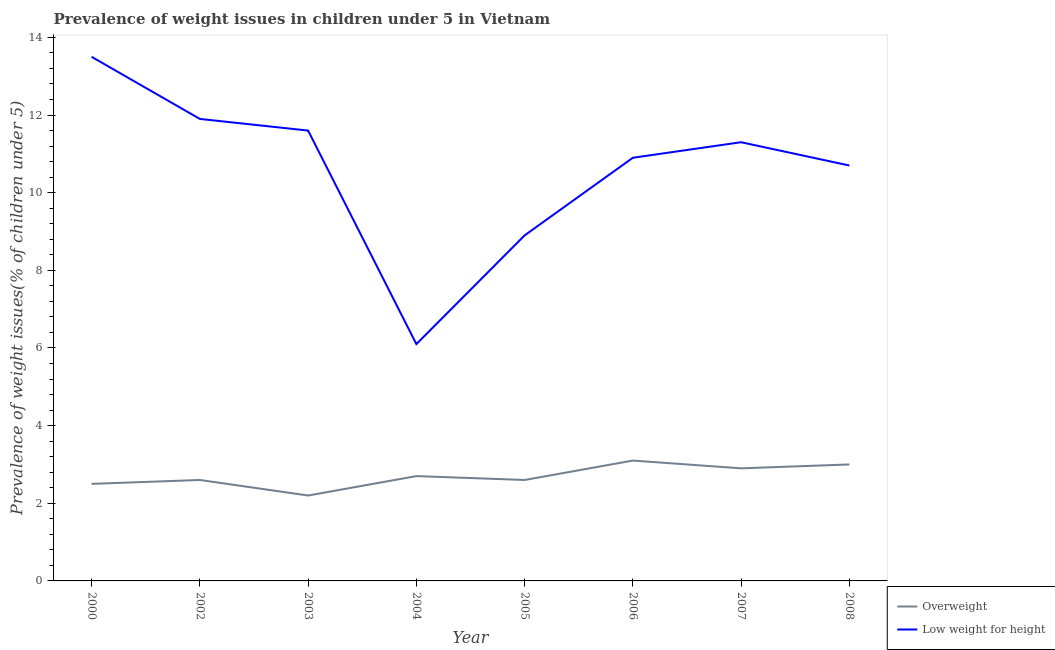How many different coloured lines are there?
Make the answer very short. 2. Does the line corresponding to percentage of underweight children intersect with the line corresponding to percentage of overweight children?
Give a very brief answer. No. What is the percentage of overweight children in 2008?
Your answer should be very brief. 3. Across all years, what is the maximum percentage of overweight children?
Make the answer very short. 3.1. Across all years, what is the minimum percentage of underweight children?
Ensure brevity in your answer.  6.1. What is the total percentage of overweight children in the graph?
Your answer should be compact. 21.6. What is the difference between the percentage of overweight children in 2004 and that in 2008?
Your response must be concise. -0.3. What is the difference between the percentage of overweight children in 2004 and the percentage of underweight children in 2005?
Make the answer very short. -6.2. What is the average percentage of underweight children per year?
Your answer should be compact. 10.61. In the year 2002, what is the difference between the percentage of overweight children and percentage of underweight children?
Give a very brief answer. -9.3. What is the ratio of the percentage of underweight children in 2003 to that in 2006?
Keep it short and to the point. 1.06. Is the difference between the percentage of underweight children in 2002 and 2006 greater than the difference between the percentage of overweight children in 2002 and 2006?
Make the answer very short. Yes. What is the difference between the highest and the second highest percentage of overweight children?
Your answer should be compact. 0.1. What is the difference between the highest and the lowest percentage of underweight children?
Ensure brevity in your answer.  7.4. Does the percentage of underweight children monotonically increase over the years?
Your answer should be very brief. No. Is the percentage of underweight children strictly less than the percentage of overweight children over the years?
Your answer should be compact. No. How many lines are there?
Provide a short and direct response. 2. How many years are there in the graph?
Give a very brief answer. 8. What is the difference between two consecutive major ticks on the Y-axis?
Ensure brevity in your answer.  2. Does the graph contain grids?
Offer a very short reply. No. Where does the legend appear in the graph?
Keep it short and to the point. Bottom right. What is the title of the graph?
Offer a terse response. Prevalence of weight issues in children under 5 in Vietnam. Does "Investment in Telecom" appear as one of the legend labels in the graph?
Keep it short and to the point. No. What is the label or title of the X-axis?
Make the answer very short. Year. What is the label or title of the Y-axis?
Make the answer very short. Prevalence of weight issues(% of children under 5). What is the Prevalence of weight issues(% of children under 5) of Overweight in 2000?
Make the answer very short. 2.5. What is the Prevalence of weight issues(% of children under 5) in Low weight for height in 2000?
Your answer should be very brief. 13.5. What is the Prevalence of weight issues(% of children under 5) of Overweight in 2002?
Give a very brief answer. 2.6. What is the Prevalence of weight issues(% of children under 5) of Low weight for height in 2002?
Provide a succinct answer. 11.9. What is the Prevalence of weight issues(% of children under 5) in Overweight in 2003?
Your answer should be compact. 2.2. What is the Prevalence of weight issues(% of children under 5) of Low weight for height in 2003?
Your answer should be compact. 11.6. What is the Prevalence of weight issues(% of children under 5) of Overweight in 2004?
Make the answer very short. 2.7. What is the Prevalence of weight issues(% of children under 5) in Low weight for height in 2004?
Ensure brevity in your answer.  6.1. What is the Prevalence of weight issues(% of children under 5) of Overweight in 2005?
Offer a terse response. 2.6. What is the Prevalence of weight issues(% of children under 5) in Low weight for height in 2005?
Your answer should be very brief. 8.9. What is the Prevalence of weight issues(% of children under 5) of Overweight in 2006?
Offer a very short reply. 3.1. What is the Prevalence of weight issues(% of children under 5) of Low weight for height in 2006?
Give a very brief answer. 10.9. What is the Prevalence of weight issues(% of children under 5) of Overweight in 2007?
Make the answer very short. 2.9. What is the Prevalence of weight issues(% of children under 5) in Low weight for height in 2007?
Your answer should be compact. 11.3. What is the Prevalence of weight issues(% of children under 5) of Overweight in 2008?
Keep it short and to the point. 3. What is the Prevalence of weight issues(% of children under 5) of Low weight for height in 2008?
Your answer should be very brief. 10.7. Across all years, what is the maximum Prevalence of weight issues(% of children under 5) of Overweight?
Your answer should be compact. 3.1. Across all years, what is the maximum Prevalence of weight issues(% of children under 5) in Low weight for height?
Offer a terse response. 13.5. Across all years, what is the minimum Prevalence of weight issues(% of children under 5) in Overweight?
Provide a short and direct response. 2.2. Across all years, what is the minimum Prevalence of weight issues(% of children under 5) of Low weight for height?
Your answer should be compact. 6.1. What is the total Prevalence of weight issues(% of children under 5) of Overweight in the graph?
Provide a succinct answer. 21.6. What is the total Prevalence of weight issues(% of children under 5) in Low weight for height in the graph?
Ensure brevity in your answer.  84.9. What is the difference between the Prevalence of weight issues(% of children under 5) of Overweight in 2000 and that in 2002?
Keep it short and to the point. -0.1. What is the difference between the Prevalence of weight issues(% of children under 5) of Low weight for height in 2000 and that in 2002?
Ensure brevity in your answer.  1.6. What is the difference between the Prevalence of weight issues(% of children under 5) of Low weight for height in 2000 and that in 2003?
Offer a terse response. 1.9. What is the difference between the Prevalence of weight issues(% of children under 5) in Low weight for height in 2000 and that in 2004?
Your response must be concise. 7.4. What is the difference between the Prevalence of weight issues(% of children under 5) of Overweight in 2000 and that in 2005?
Ensure brevity in your answer.  -0.1. What is the difference between the Prevalence of weight issues(% of children under 5) in Overweight in 2000 and that in 2007?
Provide a short and direct response. -0.4. What is the difference between the Prevalence of weight issues(% of children under 5) of Low weight for height in 2000 and that in 2007?
Make the answer very short. 2.2. What is the difference between the Prevalence of weight issues(% of children under 5) in Overweight in 2002 and that in 2004?
Offer a very short reply. -0.1. What is the difference between the Prevalence of weight issues(% of children under 5) of Low weight for height in 2002 and that in 2005?
Make the answer very short. 3. What is the difference between the Prevalence of weight issues(% of children under 5) of Overweight in 2002 and that in 2006?
Make the answer very short. -0.5. What is the difference between the Prevalence of weight issues(% of children under 5) of Low weight for height in 2002 and that in 2006?
Offer a very short reply. 1. What is the difference between the Prevalence of weight issues(% of children under 5) in Overweight in 2002 and that in 2007?
Your answer should be compact. -0.3. What is the difference between the Prevalence of weight issues(% of children under 5) in Overweight in 2002 and that in 2008?
Offer a very short reply. -0.4. What is the difference between the Prevalence of weight issues(% of children under 5) of Low weight for height in 2002 and that in 2008?
Your answer should be very brief. 1.2. What is the difference between the Prevalence of weight issues(% of children under 5) in Overweight in 2003 and that in 2004?
Make the answer very short. -0.5. What is the difference between the Prevalence of weight issues(% of children under 5) of Overweight in 2003 and that in 2006?
Ensure brevity in your answer.  -0.9. What is the difference between the Prevalence of weight issues(% of children under 5) in Overweight in 2003 and that in 2007?
Give a very brief answer. -0.7. What is the difference between the Prevalence of weight issues(% of children under 5) of Overweight in 2003 and that in 2008?
Your answer should be compact. -0.8. What is the difference between the Prevalence of weight issues(% of children under 5) of Overweight in 2004 and that in 2005?
Your response must be concise. 0.1. What is the difference between the Prevalence of weight issues(% of children under 5) of Overweight in 2005 and that in 2006?
Ensure brevity in your answer.  -0.5. What is the difference between the Prevalence of weight issues(% of children under 5) in Low weight for height in 2005 and that in 2007?
Ensure brevity in your answer.  -2.4. What is the difference between the Prevalence of weight issues(% of children under 5) of Overweight in 2005 and that in 2008?
Provide a succinct answer. -0.4. What is the difference between the Prevalence of weight issues(% of children under 5) in Overweight in 2006 and that in 2008?
Your answer should be very brief. 0.1. What is the difference between the Prevalence of weight issues(% of children under 5) of Low weight for height in 2006 and that in 2008?
Provide a short and direct response. 0.2. What is the difference between the Prevalence of weight issues(% of children under 5) of Overweight in 2007 and that in 2008?
Your answer should be very brief. -0.1. What is the difference between the Prevalence of weight issues(% of children under 5) in Low weight for height in 2007 and that in 2008?
Offer a very short reply. 0.6. What is the difference between the Prevalence of weight issues(% of children under 5) of Overweight in 2000 and the Prevalence of weight issues(% of children under 5) of Low weight for height in 2002?
Provide a short and direct response. -9.4. What is the difference between the Prevalence of weight issues(% of children under 5) in Overweight in 2000 and the Prevalence of weight issues(% of children under 5) in Low weight for height in 2003?
Offer a very short reply. -9.1. What is the difference between the Prevalence of weight issues(% of children under 5) in Overweight in 2000 and the Prevalence of weight issues(% of children under 5) in Low weight for height in 2004?
Provide a short and direct response. -3.6. What is the difference between the Prevalence of weight issues(% of children under 5) of Overweight in 2000 and the Prevalence of weight issues(% of children under 5) of Low weight for height in 2005?
Give a very brief answer. -6.4. What is the difference between the Prevalence of weight issues(% of children under 5) in Overweight in 2002 and the Prevalence of weight issues(% of children under 5) in Low weight for height in 2005?
Make the answer very short. -6.3. What is the difference between the Prevalence of weight issues(% of children under 5) in Overweight in 2003 and the Prevalence of weight issues(% of children under 5) in Low weight for height in 2004?
Your response must be concise. -3.9. What is the difference between the Prevalence of weight issues(% of children under 5) of Overweight in 2003 and the Prevalence of weight issues(% of children under 5) of Low weight for height in 2006?
Give a very brief answer. -8.7. What is the difference between the Prevalence of weight issues(% of children under 5) of Overweight in 2003 and the Prevalence of weight issues(% of children under 5) of Low weight for height in 2007?
Provide a succinct answer. -9.1. What is the difference between the Prevalence of weight issues(% of children under 5) of Overweight in 2004 and the Prevalence of weight issues(% of children under 5) of Low weight for height in 2005?
Provide a succinct answer. -6.2. What is the difference between the Prevalence of weight issues(% of children under 5) in Overweight in 2004 and the Prevalence of weight issues(% of children under 5) in Low weight for height in 2007?
Ensure brevity in your answer.  -8.6. What is the difference between the Prevalence of weight issues(% of children under 5) in Overweight in 2004 and the Prevalence of weight issues(% of children under 5) in Low weight for height in 2008?
Give a very brief answer. -8. What is the difference between the Prevalence of weight issues(% of children under 5) of Overweight in 2005 and the Prevalence of weight issues(% of children under 5) of Low weight for height in 2006?
Offer a very short reply. -8.3. What is the difference between the Prevalence of weight issues(% of children under 5) in Overweight in 2005 and the Prevalence of weight issues(% of children under 5) in Low weight for height in 2007?
Your answer should be compact. -8.7. What is the difference between the Prevalence of weight issues(% of children under 5) in Overweight in 2005 and the Prevalence of weight issues(% of children under 5) in Low weight for height in 2008?
Give a very brief answer. -8.1. What is the difference between the Prevalence of weight issues(% of children under 5) in Overweight in 2007 and the Prevalence of weight issues(% of children under 5) in Low weight for height in 2008?
Offer a terse response. -7.8. What is the average Prevalence of weight issues(% of children under 5) in Overweight per year?
Make the answer very short. 2.7. What is the average Prevalence of weight issues(% of children under 5) of Low weight for height per year?
Ensure brevity in your answer.  10.61. In the year 2000, what is the difference between the Prevalence of weight issues(% of children under 5) in Overweight and Prevalence of weight issues(% of children under 5) in Low weight for height?
Offer a terse response. -11. In the year 2002, what is the difference between the Prevalence of weight issues(% of children under 5) in Overweight and Prevalence of weight issues(% of children under 5) in Low weight for height?
Your answer should be very brief. -9.3. In the year 2003, what is the difference between the Prevalence of weight issues(% of children under 5) in Overweight and Prevalence of weight issues(% of children under 5) in Low weight for height?
Offer a terse response. -9.4. In the year 2004, what is the difference between the Prevalence of weight issues(% of children under 5) of Overweight and Prevalence of weight issues(% of children under 5) of Low weight for height?
Ensure brevity in your answer.  -3.4. In the year 2005, what is the difference between the Prevalence of weight issues(% of children under 5) in Overweight and Prevalence of weight issues(% of children under 5) in Low weight for height?
Provide a short and direct response. -6.3. In the year 2006, what is the difference between the Prevalence of weight issues(% of children under 5) in Overweight and Prevalence of weight issues(% of children under 5) in Low weight for height?
Your answer should be very brief. -7.8. In the year 2007, what is the difference between the Prevalence of weight issues(% of children under 5) in Overweight and Prevalence of weight issues(% of children under 5) in Low weight for height?
Offer a terse response. -8.4. What is the ratio of the Prevalence of weight issues(% of children under 5) of Overweight in 2000 to that in 2002?
Offer a terse response. 0.96. What is the ratio of the Prevalence of weight issues(% of children under 5) of Low weight for height in 2000 to that in 2002?
Make the answer very short. 1.13. What is the ratio of the Prevalence of weight issues(% of children under 5) of Overweight in 2000 to that in 2003?
Offer a very short reply. 1.14. What is the ratio of the Prevalence of weight issues(% of children under 5) of Low weight for height in 2000 to that in 2003?
Offer a very short reply. 1.16. What is the ratio of the Prevalence of weight issues(% of children under 5) in Overweight in 2000 to that in 2004?
Provide a succinct answer. 0.93. What is the ratio of the Prevalence of weight issues(% of children under 5) in Low weight for height in 2000 to that in 2004?
Your response must be concise. 2.21. What is the ratio of the Prevalence of weight issues(% of children under 5) in Overweight in 2000 to that in 2005?
Your answer should be compact. 0.96. What is the ratio of the Prevalence of weight issues(% of children under 5) in Low weight for height in 2000 to that in 2005?
Provide a succinct answer. 1.52. What is the ratio of the Prevalence of weight issues(% of children under 5) of Overweight in 2000 to that in 2006?
Ensure brevity in your answer.  0.81. What is the ratio of the Prevalence of weight issues(% of children under 5) in Low weight for height in 2000 to that in 2006?
Your answer should be very brief. 1.24. What is the ratio of the Prevalence of weight issues(% of children under 5) in Overweight in 2000 to that in 2007?
Keep it short and to the point. 0.86. What is the ratio of the Prevalence of weight issues(% of children under 5) of Low weight for height in 2000 to that in 2007?
Ensure brevity in your answer.  1.19. What is the ratio of the Prevalence of weight issues(% of children under 5) of Low weight for height in 2000 to that in 2008?
Your answer should be compact. 1.26. What is the ratio of the Prevalence of weight issues(% of children under 5) of Overweight in 2002 to that in 2003?
Give a very brief answer. 1.18. What is the ratio of the Prevalence of weight issues(% of children under 5) in Low weight for height in 2002 to that in 2003?
Give a very brief answer. 1.03. What is the ratio of the Prevalence of weight issues(% of children under 5) in Overweight in 2002 to that in 2004?
Offer a very short reply. 0.96. What is the ratio of the Prevalence of weight issues(% of children under 5) of Low weight for height in 2002 to that in 2004?
Give a very brief answer. 1.95. What is the ratio of the Prevalence of weight issues(% of children under 5) in Overweight in 2002 to that in 2005?
Provide a short and direct response. 1. What is the ratio of the Prevalence of weight issues(% of children under 5) in Low weight for height in 2002 to that in 2005?
Ensure brevity in your answer.  1.34. What is the ratio of the Prevalence of weight issues(% of children under 5) of Overweight in 2002 to that in 2006?
Provide a short and direct response. 0.84. What is the ratio of the Prevalence of weight issues(% of children under 5) of Low weight for height in 2002 to that in 2006?
Your answer should be very brief. 1.09. What is the ratio of the Prevalence of weight issues(% of children under 5) of Overweight in 2002 to that in 2007?
Offer a terse response. 0.9. What is the ratio of the Prevalence of weight issues(% of children under 5) in Low weight for height in 2002 to that in 2007?
Your response must be concise. 1.05. What is the ratio of the Prevalence of weight issues(% of children under 5) of Overweight in 2002 to that in 2008?
Ensure brevity in your answer.  0.87. What is the ratio of the Prevalence of weight issues(% of children under 5) in Low weight for height in 2002 to that in 2008?
Provide a short and direct response. 1.11. What is the ratio of the Prevalence of weight issues(% of children under 5) in Overweight in 2003 to that in 2004?
Keep it short and to the point. 0.81. What is the ratio of the Prevalence of weight issues(% of children under 5) in Low weight for height in 2003 to that in 2004?
Provide a short and direct response. 1.9. What is the ratio of the Prevalence of weight issues(% of children under 5) in Overweight in 2003 to that in 2005?
Keep it short and to the point. 0.85. What is the ratio of the Prevalence of weight issues(% of children under 5) in Low weight for height in 2003 to that in 2005?
Provide a short and direct response. 1.3. What is the ratio of the Prevalence of weight issues(% of children under 5) in Overweight in 2003 to that in 2006?
Your answer should be compact. 0.71. What is the ratio of the Prevalence of weight issues(% of children under 5) of Low weight for height in 2003 to that in 2006?
Offer a very short reply. 1.06. What is the ratio of the Prevalence of weight issues(% of children under 5) in Overweight in 2003 to that in 2007?
Make the answer very short. 0.76. What is the ratio of the Prevalence of weight issues(% of children under 5) in Low weight for height in 2003 to that in 2007?
Your answer should be compact. 1.03. What is the ratio of the Prevalence of weight issues(% of children under 5) of Overweight in 2003 to that in 2008?
Offer a very short reply. 0.73. What is the ratio of the Prevalence of weight issues(% of children under 5) in Low weight for height in 2003 to that in 2008?
Make the answer very short. 1.08. What is the ratio of the Prevalence of weight issues(% of children under 5) in Overweight in 2004 to that in 2005?
Give a very brief answer. 1.04. What is the ratio of the Prevalence of weight issues(% of children under 5) of Low weight for height in 2004 to that in 2005?
Offer a very short reply. 0.69. What is the ratio of the Prevalence of weight issues(% of children under 5) of Overweight in 2004 to that in 2006?
Ensure brevity in your answer.  0.87. What is the ratio of the Prevalence of weight issues(% of children under 5) of Low weight for height in 2004 to that in 2006?
Your response must be concise. 0.56. What is the ratio of the Prevalence of weight issues(% of children under 5) in Low weight for height in 2004 to that in 2007?
Make the answer very short. 0.54. What is the ratio of the Prevalence of weight issues(% of children under 5) of Overweight in 2004 to that in 2008?
Provide a succinct answer. 0.9. What is the ratio of the Prevalence of weight issues(% of children under 5) in Low weight for height in 2004 to that in 2008?
Ensure brevity in your answer.  0.57. What is the ratio of the Prevalence of weight issues(% of children under 5) of Overweight in 2005 to that in 2006?
Your answer should be compact. 0.84. What is the ratio of the Prevalence of weight issues(% of children under 5) in Low weight for height in 2005 to that in 2006?
Provide a short and direct response. 0.82. What is the ratio of the Prevalence of weight issues(% of children under 5) in Overweight in 2005 to that in 2007?
Your answer should be compact. 0.9. What is the ratio of the Prevalence of weight issues(% of children under 5) of Low weight for height in 2005 to that in 2007?
Keep it short and to the point. 0.79. What is the ratio of the Prevalence of weight issues(% of children under 5) of Overweight in 2005 to that in 2008?
Give a very brief answer. 0.87. What is the ratio of the Prevalence of weight issues(% of children under 5) in Low weight for height in 2005 to that in 2008?
Your answer should be very brief. 0.83. What is the ratio of the Prevalence of weight issues(% of children under 5) of Overweight in 2006 to that in 2007?
Your answer should be very brief. 1.07. What is the ratio of the Prevalence of weight issues(% of children under 5) in Low weight for height in 2006 to that in 2007?
Provide a short and direct response. 0.96. What is the ratio of the Prevalence of weight issues(% of children under 5) of Low weight for height in 2006 to that in 2008?
Provide a succinct answer. 1.02. What is the ratio of the Prevalence of weight issues(% of children under 5) of Overweight in 2007 to that in 2008?
Make the answer very short. 0.97. What is the ratio of the Prevalence of weight issues(% of children under 5) of Low weight for height in 2007 to that in 2008?
Your answer should be very brief. 1.06. What is the difference between the highest and the second highest Prevalence of weight issues(% of children under 5) in Overweight?
Your response must be concise. 0.1. What is the difference between the highest and the lowest Prevalence of weight issues(% of children under 5) in Overweight?
Offer a very short reply. 0.9. What is the difference between the highest and the lowest Prevalence of weight issues(% of children under 5) of Low weight for height?
Your answer should be compact. 7.4. 